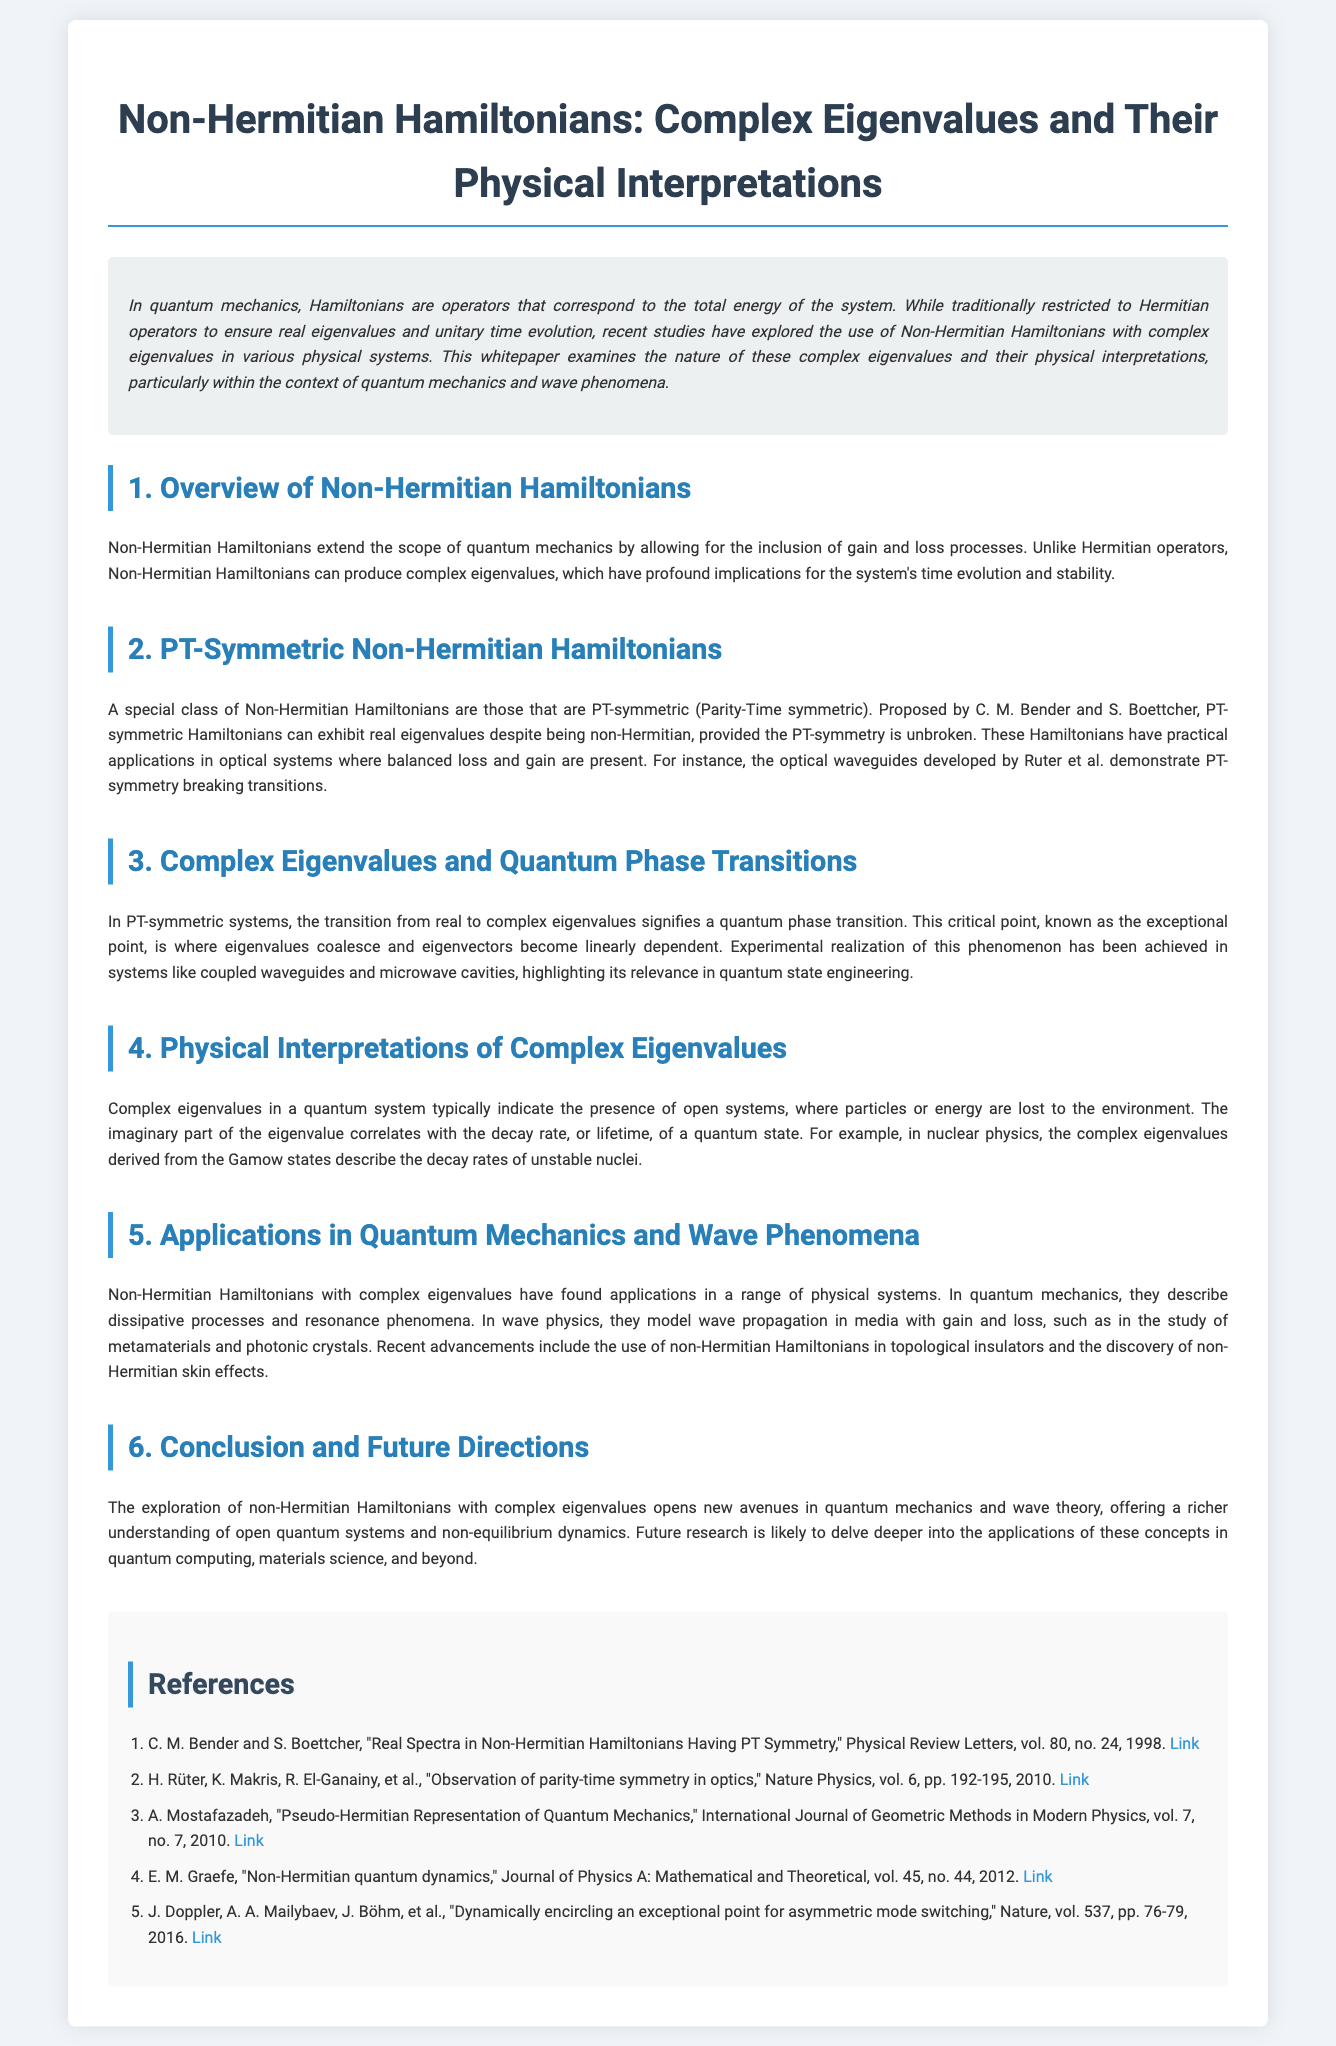What is the primary focus of the whitepaper? The introduction states that the whitepaper examines the nature of complex eigenvalues and their physical interpretations in quantum mechanics and wave phenomena.
Answer: complex eigenvalues and their physical interpretations Who proposed the concept of PT-symmetric Hamiltonians? The section on PT-Symmetric Non-Hermitian Hamiltonians mentions that C. M. Bender and S. Boettcher proposed the concept.
Answer: C. M. Bender and S. Boettcher What phenomenon does the transition from real to complex eigenvalues signify? The section on Complex Eigenvalues and Quantum Phase Transitions explains that this transition signifies a quantum phase transition.
Answer: quantum phase transition What is one application mentioned for Non-Hermitian Hamiltonians? The section on Applications in Quantum Mechanics and Wave Phenomena states that they describe dissipative processes and resonance phenomena.
Answer: dissipative processes and resonance phenomena What term is used for the critical point where eigenvalues coalesce? The section on Complex Eigenvalues and Quantum Phase Transitions refers to this critical point as the exceptional point.
Answer: exceptional point In what type of physics are complex eigenvalues derived from Gamow states discussed? The section on Physical Interpretations of Complex Eigenvalues mentions nuclear physics in relation to Gamow states and complex eigenvalues.
Answer: nuclear physics What year was the paper by Rüter et al. published? The reference for Rüter et al. indicates it was published in 2010.
Answer: 2010 What do complex eigenvalues typically indicate about a quantum system? The section on Physical Interpretations of Complex Eigenvalues mentions that they typically indicate the presence of open systems.
Answer: open systems 